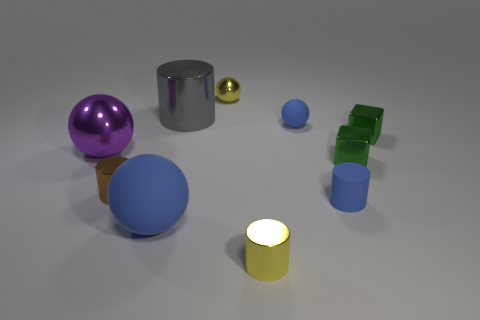Subtract all yellow blocks. How many blue spheres are left? 2 Subtract all purple spheres. How many spheres are left? 3 Subtract 1 spheres. How many spheres are left? 3 Subtract all blue balls. How many balls are left? 2 Subtract all yellow cylinders. Subtract all gray balls. How many cylinders are left? 3 Subtract all large spheres. Subtract all big metallic spheres. How many objects are left? 7 Add 8 big rubber objects. How many big rubber objects are left? 9 Add 8 small gray metal cubes. How many small gray metal cubes exist? 8 Subtract 0 green balls. How many objects are left? 10 Subtract all cubes. How many objects are left? 8 